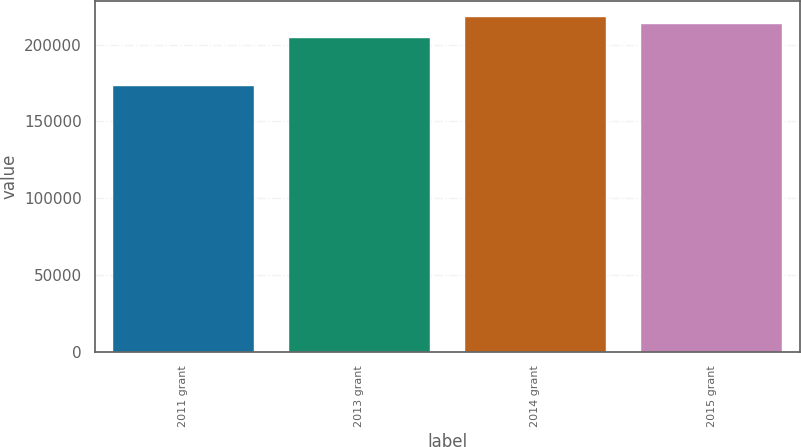Convert chart. <chart><loc_0><loc_0><loc_500><loc_500><bar_chart><fcel>2011 grant<fcel>2013 grant<fcel>2014 grant<fcel>2015 grant<nl><fcel>172850<fcel>204500<fcel>217640<fcel>213250<nl></chart> 